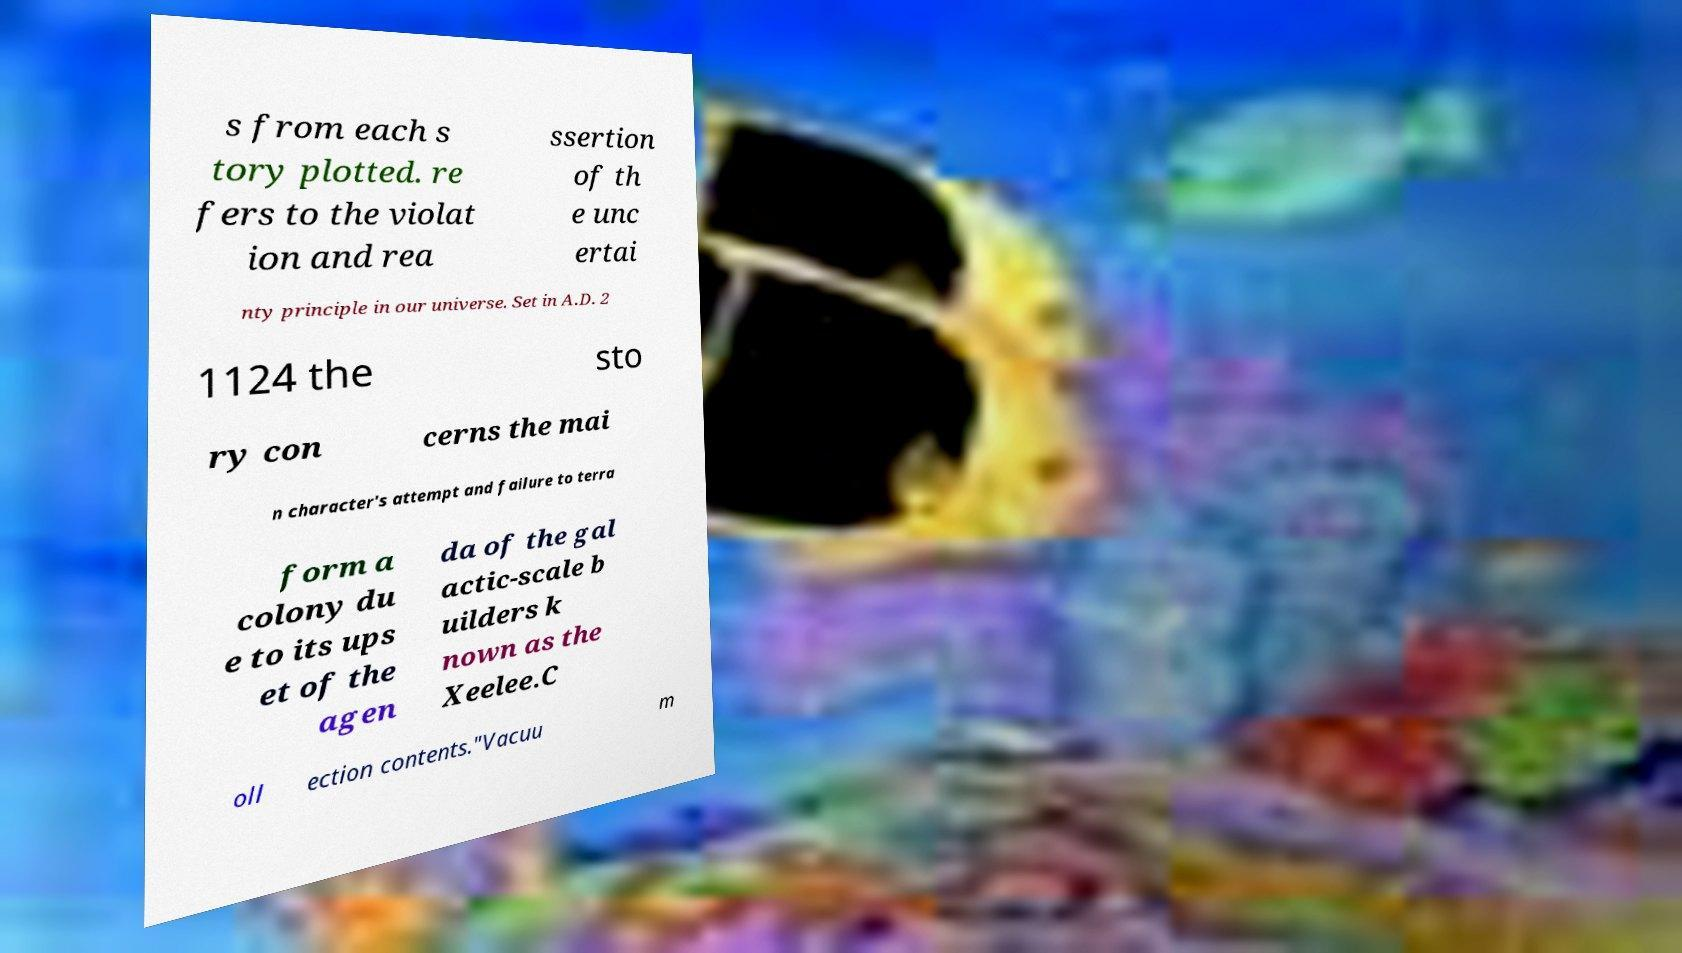For documentation purposes, I need the text within this image transcribed. Could you provide that? s from each s tory plotted. re fers to the violat ion and rea ssertion of th e unc ertai nty principle in our universe. Set in A.D. 2 1124 the sto ry con cerns the mai n character's attempt and failure to terra form a colony du e to its ups et of the agen da of the gal actic-scale b uilders k nown as the Xeelee.C oll ection contents."Vacuu m 